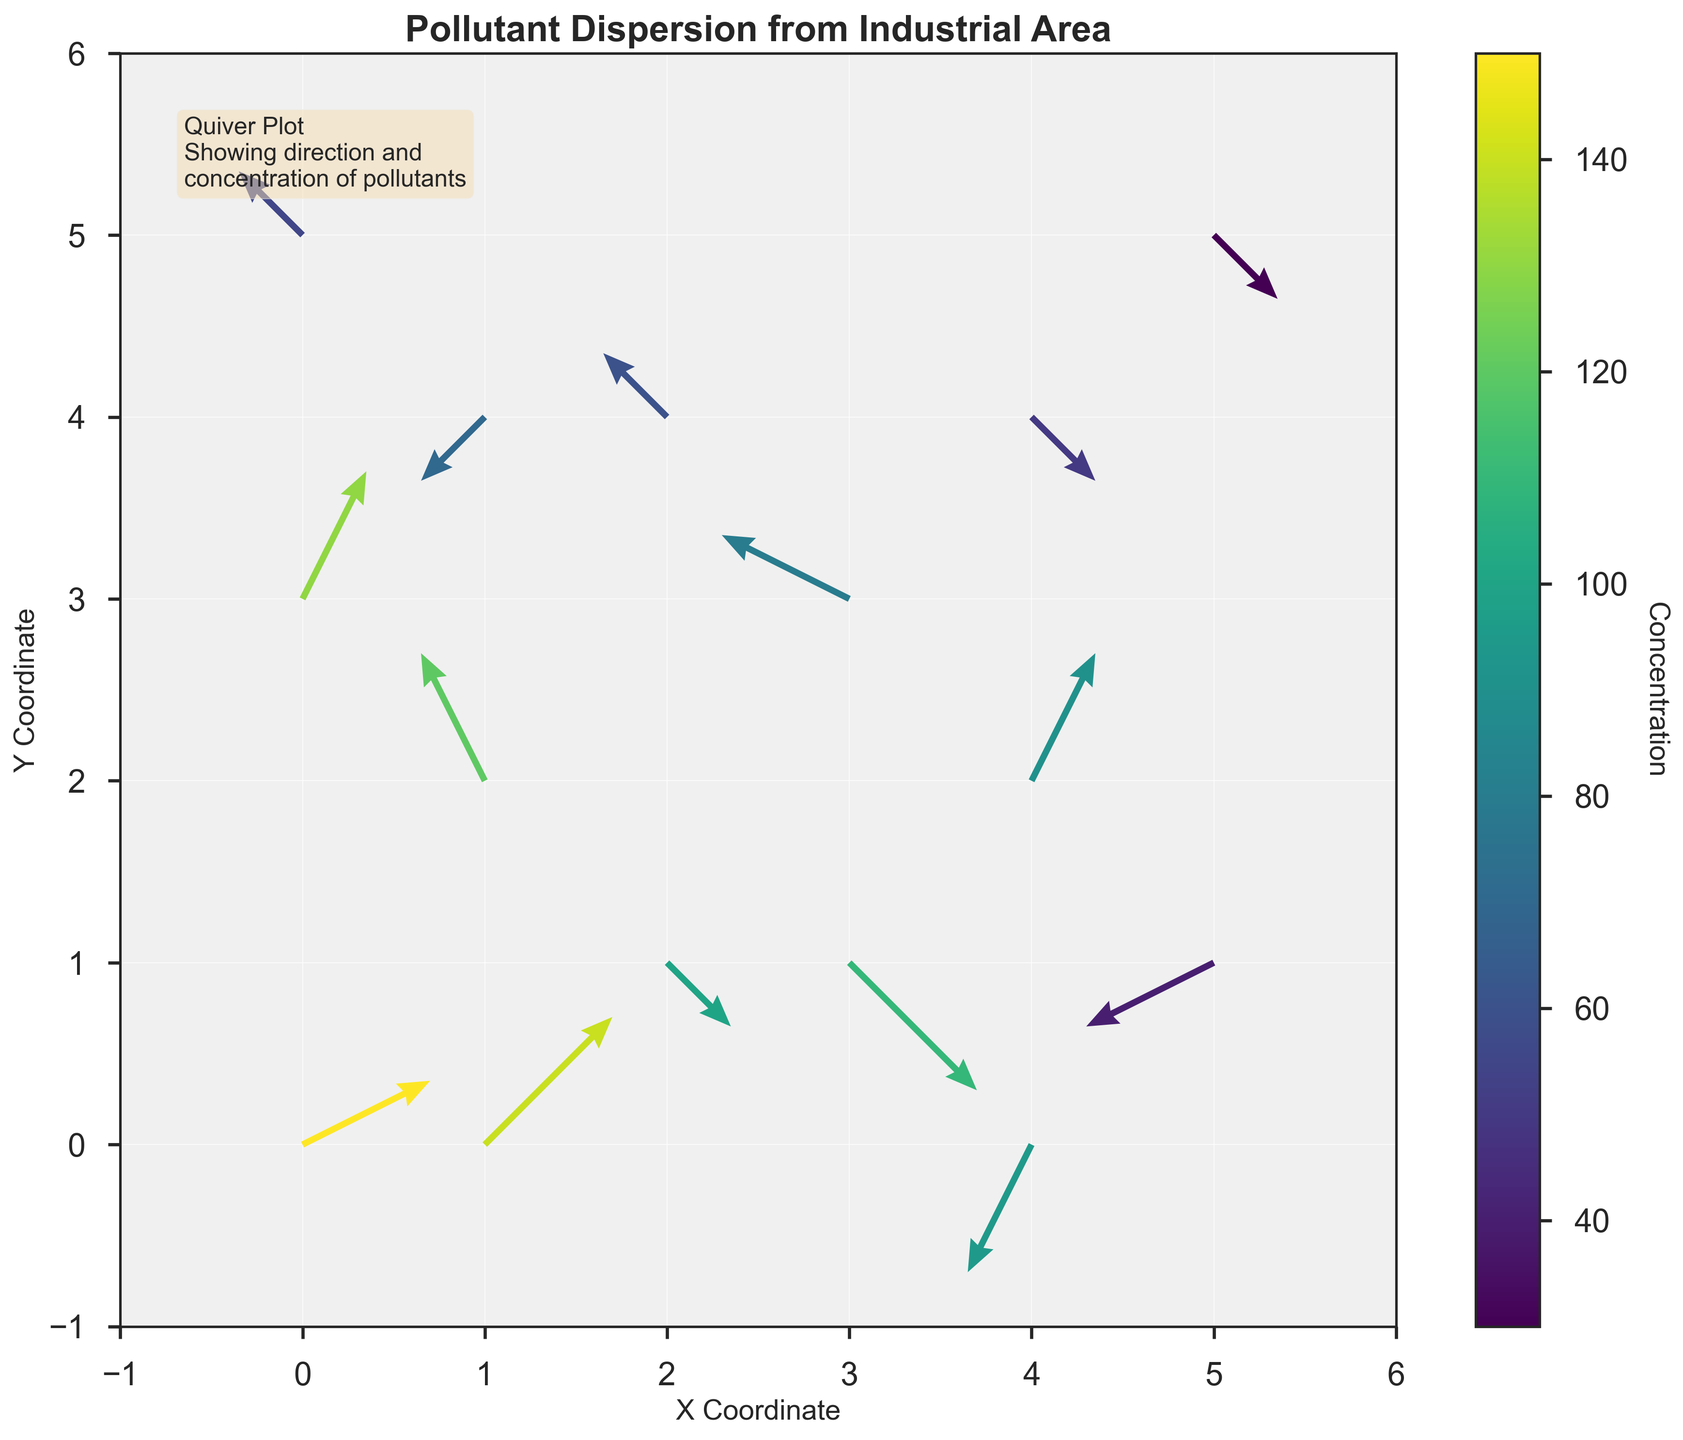What's the title of the figure? The title is usually shown at the top of the figure and summarizes the main theme. Here, you can read the title as "Pollutant Dispersion from Industrial Area"
Answer: Pollutant Dispersion from Industrial Area What does the color bar represent? The color bar provides a reference for the different colors in the quiver plot. It helps to understand the magnitude of the pollutant concentration linked to each arrow in the plot. It is labeled as "Concentration" with a range of values showing how concentration varies.
Answer: Concentration How many arrows are there in the quiver plot? Each arrow represents a data point that shows direction and magnitude of pollutant dispersion. By visually counting them in the plot, you can determine the total number. Here, you see there are 15 arrows.
Answer: 15 At which coordinates do you find the highest concentration of pollutants? Concentration values are color-coded, with lighter colors indicating higher concentrations. By observing the color closest to the top of the color bar and matching it to the coordinates, you can determine the highest concentration value. The highest concentration is at coordinates (0, 0) with a value of 150.
Answer: (0, 0) Which arrow has the longest vector in the plot? The length of the arrows in the quiver plot indicates vector magnitude. By visually comparing the arrows, you can identify the longest one. In this plot, the vector at coordinates (1, 0) and (1, 4) both appear as some of the longest arrows.
Answer: (1, 0) and (1, 4) What direction is the pollutant dispersing from the point (5, 1)? The direction of dispersion is indicated by the orientation of the arrow at that point. The arrow at (5, 1) points downwards and slightly left, indicating the pollutants are moving in that direction.
Answer: Down-left Which region (quadrant) of the plot shows the least pollutant concentration? By scanning the color intensities corresponding to different quadrants of the plot, you can detect the area with darker (lower concentration) colors. Notice that position (5, 5) at the top-right has one of the least concentrations at 30.
Answer: Top-right quadrant Are there any points where the pollutants are dispersing towards the negative x-axis? By observing the direction of the arrows, you can determine if any are pointing left (negative x direction). Arrows at points (1, 2), (3, 3), (1, 4), and (5, 1) disperse towards the negative x-axis.
Answer: Yes Compare the pollutant concentrations at coordinates (2, 1) and (3, 1). Which one is higher? Look at the color coding for each coordinate and refer to the concentration values given. At (2, 1), the concentration is 100, and at (3, 1), it is 110. Therefore, (3, 1) has a higher concentration.
Answer: (3, 1) What is the general trend of pollutant movement in the top half of the plot? By observing the arrows' directions in the upper half of the plot, you can infer a general trend. Most arrows in the top half tend to point in various directions, indicating a likely average movement towards the right and upwards.
Answer: Moving right and upwards 